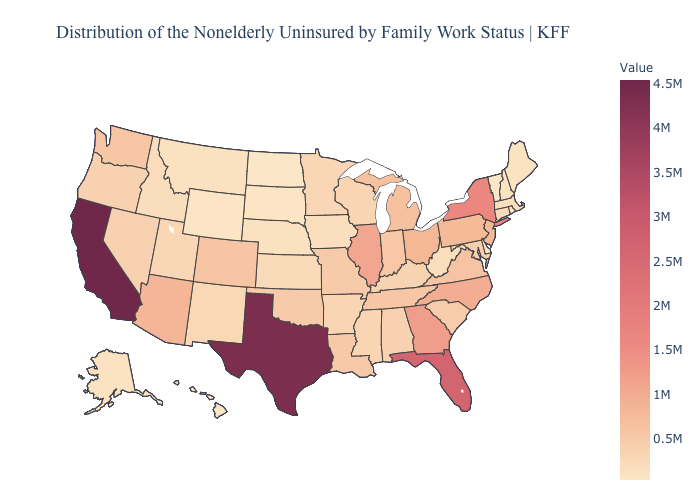Which states have the highest value in the USA?
Concise answer only. California. Does Nebraska have a lower value than Pennsylvania?
Answer briefly. Yes. Does Alaska have the highest value in the West?
Short answer required. No. Which states hav the highest value in the South?
Short answer required. Texas. Does the map have missing data?
Concise answer only. No. 